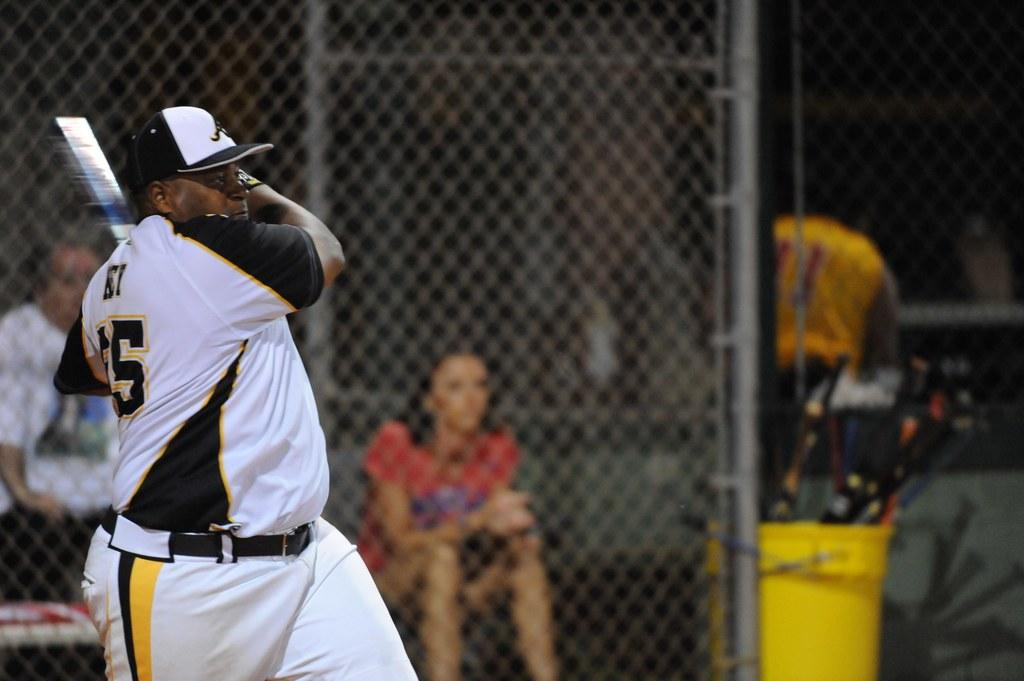<image>
Share a concise interpretation of the image provided. a person with the number 5 on their jersey swinging at a ball 